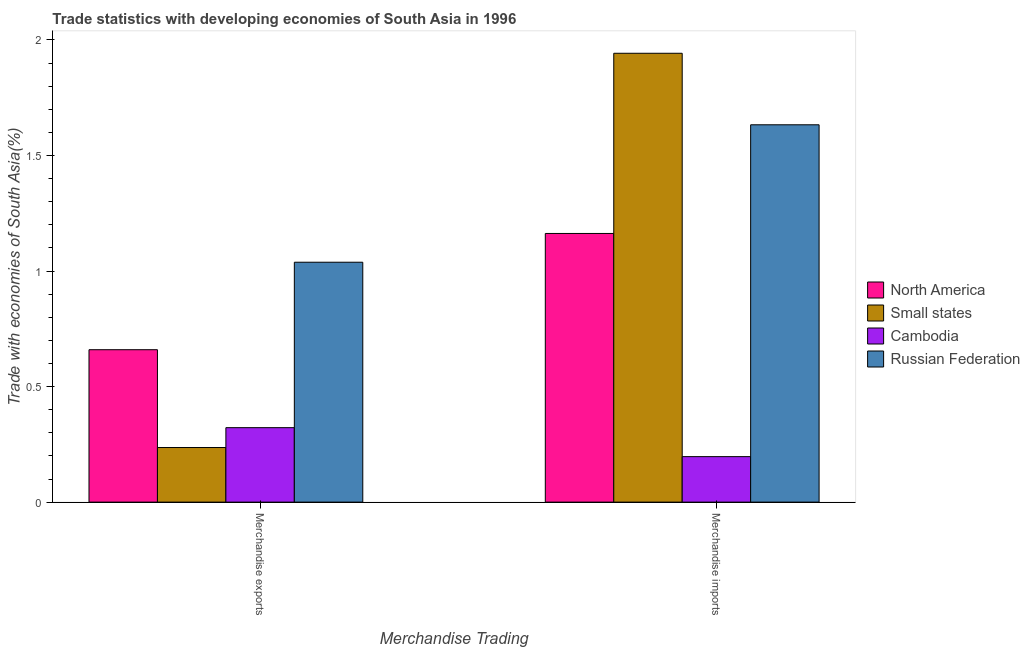How many groups of bars are there?
Provide a succinct answer. 2. Are the number of bars per tick equal to the number of legend labels?
Make the answer very short. Yes. Are the number of bars on each tick of the X-axis equal?
Offer a very short reply. Yes. How many bars are there on the 2nd tick from the left?
Your answer should be compact. 4. What is the merchandise exports in North America?
Offer a terse response. 0.66. Across all countries, what is the maximum merchandise exports?
Your answer should be very brief. 1.04. Across all countries, what is the minimum merchandise exports?
Make the answer very short. 0.24. In which country was the merchandise imports maximum?
Your answer should be compact. Small states. In which country was the merchandise imports minimum?
Make the answer very short. Cambodia. What is the total merchandise exports in the graph?
Your response must be concise. 2.26. What is the difference between the merchandise imports in North America and that in Cambodia?
Offer a terse response. 0.97. What is the difference between the merchandise exports in North America and the merchandise imports in Cambodia?
Your answer should be very brief. 0.46. What is the average merchandise imports per country?
Your response must be concise. 1.23. What is the difference between the merchandise exports and merchandise imports in Russian Federation?
Offer a terse response. -0.59. What is the ratio of the merchandise imports in North America to that in Small states?
Offer a terse response. 0.6. Is the merchandise exports in North America less than that in Russian Federation?
Give a very brief answer. Yes. What does the 3rd bar from the left in Merchandise imports represents?
Your answer should be compact. Cambodia. What does the 3rd bar from the right in Merchandise exports represents?
Keep it short and to the point. Small states. How many countries are there in the graph?
Offer a terse response. 4. Are the values on the major ticks of Y-axis written in scientific E-notation?
Offer a very short reply. No. Does the graph contain any zero values?
Ensure brevity in your answer.  No. Where does the legend appear in the graph?
Offer a very short reply. Center right. How many legend labels are there?
Make the answer very short. 4. How are the legend labels stacked?
Ensure brevity in your answer.  Vertical. What is the title of the graph?
Ensure brevity in your answer.  Trade statistics with developing economies of South Asia in 1996. What is the label or title of the X-axis?
Your answer should be compact. Merchandise Trading. What is the label or title of the Y-axis?
Keep it short and to the point. Trade with economies of South Asia(%). What is the Trade with economies of South Asia(%) in North America in Merchandise exports?
Offer a terse response. 0.66. What is the Trade with economies of South Asia(%) of Small states in Merchandise exports?
Give a very brief answer. 0.24. What is the Trade with economies of South Asia(%) in Cambodia in Merchandise exports?
Your answer should be compact. 0.32. What is the Trade with economies of South Asia(%) in Russian Federation in Merchandise exports?
Provide a short and direct response. 1.04. What is the Trade with economies of South Asia(%) of North America in Merchandise imports?
Ensure brevity in your answer.  1.16. What is the Trade with economies of South Asia(%) of Small states in Merchandise imports?
Make the answer very short. 1.94. What is the Trade with economies of South Asia(%) in Cambodia in Merchandise imports?
Provide a short and direct response. 0.2. What is the Trade with economies of South Asia(%) of Russian Federation in Merchandise imports?
Offer a very short reply. 1.63. Across all Merchandise Trading, what is the maximum Trade with economies of South Asia(%) of North America?
Keep it short and to the point. 1.16. Across all Merchandise Trading, what is the maximum Trade with economies of South Asia(%) of Small states?
Your response must be concise. 1.94. Across all Merchandise Trading, what is the maximum Trade with economies of South Asia(%) of Cambodia?
Keep it short and to the point. 0.32. Across all Merchandise Trading, what is the maximum Trade with economies of South Asia(%) of Russian Federation?
Make the answer very short. 1.63. Across all Merchandise Trading, what is the minimum Trade with economies of South Asia(%) of North America?
Your answer should be compact. 0.66. Across all Merchandise Trading, what is the minimum Trade with economies of South Asia(%) in Small states?
Your answer should be compact. 0.24. Across all Merchandise Trading, what is the minimum Trade with economies of South Asia(%) in Cambodia?
Ensure brevity in your answer.  0.2. Across all Merchandise Trading, what is the minimum Trade with economies of South Asia(%) in Russian Federation?
Your response must be concise. 1.04. What is the total Trade with economies of South Asia(%) of North America in the graph?
Provide a short and direct response. 1.82. What is the total Trade with economies of South Asia(%) in Small states in the graph?
Provide a succinct answer. 2.18. What is the total Trade with economies of South Asia(%) of Cambodia in the graph?
Provide a succinct answer. 0.52. What is the total Trade with economies of South Asia(%) of Russian Federation in the graph?
Ensure brevity in your answer.  2.67. What is the difference between the Trade with economies of South Asia(%) of North America in Merchandise exports and that in Merchandise imports?
Offer a terse response. -0.5. What is the difference between the Trade with economies of South Asia(%) in Small states in Merchandise exports and that in Merchandise imports?
Keep it short and to the point. -1.71. What is the difference between the Trade with economies of South Asia(%) in Cambodia in Merchandise exports and that in Merchandise imports?
Your answer should be compact. 0.13. What is the difference between the Trade with economies of South Asia(%) of Russian Federation in Merchandise exports and that in Merchandise imports?
Ensure brevity in your answer.  -0.59. What is the difference between the Trade with economies of South Asia(%) in North America in Merchandise exports and the Trade with economies of South Asia(%) in Small states in Merchandise imports?
Offer a terse response. -1.28. What is the difference between the Trade with economies of South Asia(%) in North America in Merchandise exports and the Trade with economies of South Asia(%) in Cambodia in Merchandise imports?
Offer a very short reply. 0.46. What is the difference between the Trade with economies of South Asia(%) in North America in Merchandise exports and the Trade with economies of South Asia(%) in Russian Federation in Merchandise imports?
Your answer should be very brief. -0.97. What is the difference between the Trade with economies of South Asia(%) in Small states in Merchandise exports and the Trade with economies of South Asia(%) in Cambodia in Merchandise imports?
Your answer should be very brief. 0.04. What is the difference between the Trade with economies of South Asia(%) in Small states in Merchandise exports and the Trade with economies of South Asia(%) in Russian Federation in Merchandise imports?
Keep it short and to the point. -1.4. What is the difference between the Trade with economies of South Asia(%) in Cambodia in Merchandise exports and the Trade with economies of South Asia(%) in Russian Federation in Merchandise imports?
Keep it short and to the point. -1.31. What is the average Trade with economies of South Asia(%) of North America per Merchandise Trading?
Give a very brief answer. 0.91. What is the average Trade with economies of South Asia(%) in Small states per Merchandise Trading?
Make the answer very short. 1.09. What is the average Trade with economies of South Asia(%) in Cambodia per Merchandise Trading?
Give a very brief answer. 0.26. What is the average Trade with economies of South Asia(%) in Russian Federation per Merchandise Trading?
Keep it short and to the point. 1.34. What is the difference between the Trade with economies of South Asia(%) in North America and Trade with economies of South Asia(%) in Small states in Merchandise exports?
Ensure brevity in your answer.  0.42. What is the difference between the Trade with economies of South Asia(%) of North America and Trade with economies of South Asia(%) of Cambodia in Merchandise exports?
Ensure brevity in your answer.  0.34. What is the difference between the Trade with economies of South Asia(%) of North America and Trade with economies of South Asia(%) of Russian Federation in Merchandise exports?
Offer a very short reply. -0.38. What is the difference between the Trade with economies of South Asia(%) in Small states and Trade with economies of South Asia(%) in Cambodia in Merchandise exports?
Ensure brevity in your answer.  -0.09. What is the difference between the Trade with economies of South Asia(%) of Small states and Trade with economies of South Asia(%) of Russian Federation in Merchandise exports?
Offer a very short reply. -0.8. What is the difference between the Trade with economies of South Asia(%) in Cambodia and Trade with economies of South Asia(%) in Russian Federation in Merchandise exports?
Offer a very short reply. -0.72. What is the difference between the Trade with economies of South Asia(%) of North America and Trade with economies of South Asia(%) of Small states in Merchandise imports?
Keep it short and to the point. -0.78. What is the difference between the Trade with economies of South Asia(%) of North America and Trade with economies of South Asia(%) of Cambodia in Merchandise imports?
Provide a succinct answer. 0.97. What is the difference between the Trade with economies of South Asia(%) of North America and Trade with economies of South Asia(%) of Russian Federation in Merchandise imports?
Ensure brevity in your answer.  -0.47. What is the difference between the Trade with economies of South Asia(%) of Small states and Trade with economies of South Asia(%) of Cambodia in Merchandise imports?
Your answer should be compact. 1.75. What is the difference between the Trade with economies of South Asia(%) of Small states and Trade with economies of South Asia(%) of Russian Federation in Merchandise imports?
Provide a succinct answer. 0.31. What is the difference between the Trade with economies of South Asia(%) of Cambodia and Trade with economies of South Asia(%) of Russian Federation in Merchandise imports?
Give a very brief answer. -1.44. What is the ratio of the Trade with economies of South Asia(%) in North America in Merchandise exports to that in Merchandise imports?
Provide a succinct answer. 0.57. What is the ratio of the Trade with economies of South Asia(%) of Small states in Merchandise exports to that in Merchandise imports?
Ensure brevity in your answer.  0.12. What is the ratio of the Trade with economies of South Asia(%) of Cambodia in Merchandise exports to that in Merchandise imports?
Your answer should be compact. 1.64. What is the ratio of the Trade with economies of South Asia(%) in Russian Federation in Merchandise exports to that in Merchandise imports?
Offer a very short reply. 0.64. What is the difference between the highest and the second highest Trade with economies of South Asia(%) in North America?
Your response must be concise. 0.5. What is the difference between the highest and the second highest Trade with economies of South Asia(%) of Small states?
Offer a very short reply. 1.71. What is the difference between the highest and the second highest Trade with economies of South Asia(%) of Cambodia?
Provide a short and direct response. 0.13. What is the difference between the highest and the second highest Trade with economies of South Asia(%) in Russian Federation?
Provide a succinct answer. 0.59. What is the difference between the highest and the lowest Trade with economies of South Asia(%) of North America?
Ensure brevity in your answer.  0.5. What is the difference between the highest and the lowest Trade with economies of South Asia(%) of Small states?
Offer a very short reply. 1.71. What is the difference between the highest and the lowest Trade with economies of South Asia(%) of Cambodia?
Your answer should be very brief. 0.13. What is the difference between the highest and the lowest Trade with economies of South Asia(%) in Russian Federation?
Give a very brief answer. 0.59. 